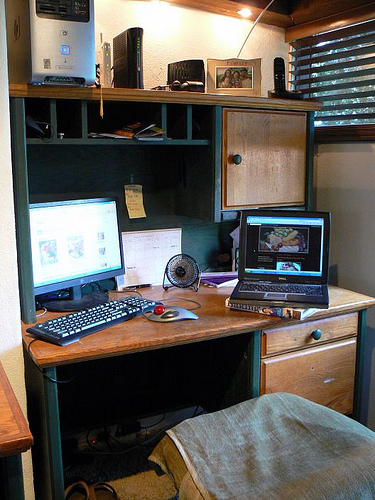<image>
Is there a computer next to the table? No. The computer is not positioned next to the table. They are located in different areas of the scene. 